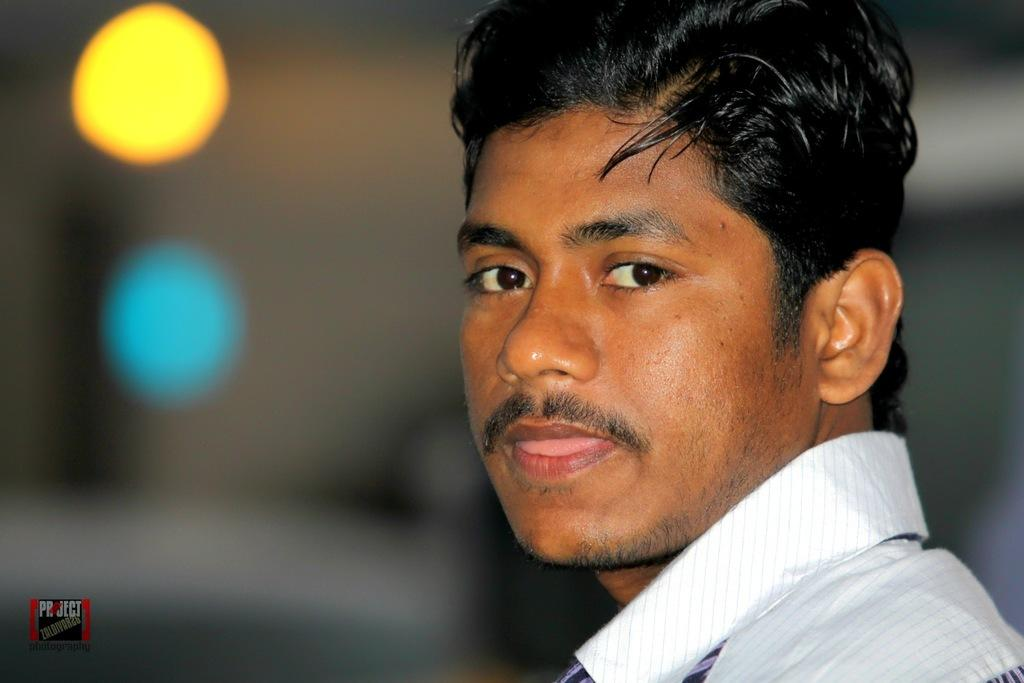What is the main subject of the image? There is a man in the image. Can you describe the background of the image? The background of the image is blurred. Is there any additional information or markings on the image? Yes, there is a watermark on the image. What type of texture can be seen on the sleet in the image? There is no sleet present in the image, so it is not possible to determine the texture of any sleet. 